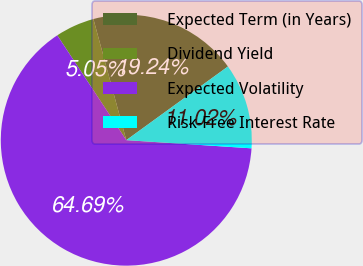<chart> <loc_0><loc_0><loc_500><loc_500><pie_chart><fcel>Expected Term (in Years)<fcel>Dividend Yield<fcel>Expected Volatility<fcel>Risk-Free Interest Rate<nl><fcel>19.24%<fcel>5.05%<fcel>64.7%<fcel>11.02%<nl></chart> 